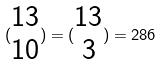<formula> <loc_0><loc_0><loc_500><loc_500>( \begin{matrix} 1 3 \\ 1 0 \end{matrix} ) = ( \begin{matrix} 1 3 \\ 3 \end{matrix} ) = 2 8 6</formula> 